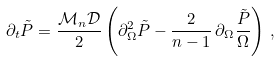<formula> <loc_0><loc_0><loc_500><loc_500>\partial _ { t } { \tilde { P } } = \frac { { \mathcal { M } } _ { n } { \mathcal { D } } } { 2 } \left ( \partial _ { \Omega } ^ { 2 } { \tilde { P } } - \frac { 2 } { n - 1 } \, \partial _ { \Omega } \frac { \tilde { P } } { \Omega } \right ) \, ,</formula> 